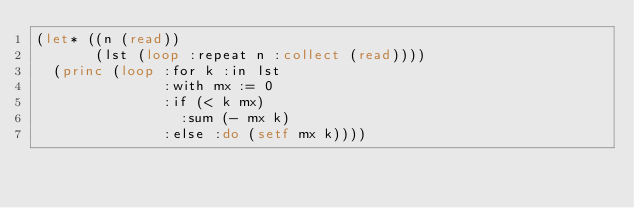Convert code to text. <code><loc_0><loc_0><loc_500><loc_500><_Lisp_>(let* ((n (read))
       (lst (loop :repeat n :collect (read))))
  (princ (loop :for k :in lst
               :with mx := 0
               :if (< k mx)
                 :sum (- mx k)
               :else :do (setf mx k))))</code> 